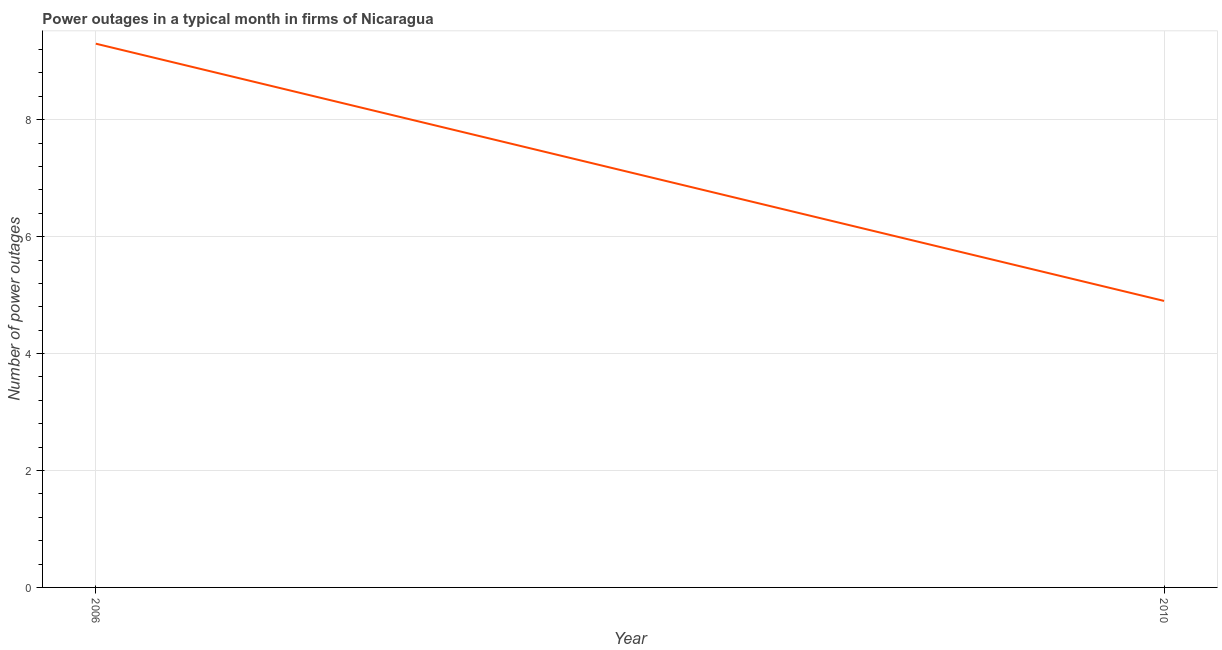What is the number of power outages in 2006?
Your answer should be very brief. 9.3. What is the sum of the number of power outages?
Provide a short and direct response. 14.2. What is the difference between the number of power outages in 2006 and 2010?
Your answer should be very brief. 4.4. What is the average number of power outages per year?
Provide a succinct answer. 7.1. What is the median number of power outages?
Provide a succinct answer. 7.1. Do a majority of the years between 2010 and 2006 (inclusive) have number of power outages greater than 8.8 ?
Provide a short and direct response. No. What is the ratio of the number of power outages in 2006 to that in 2010?
Your answer should be very brief. 1.9. In how many years, is the number of power outages greater than the average number of power outages taken over all years?
Give a very brief answer. 1. Does the number of power outages monotonically increase over the years?
Provide a short and direct response. No. How many lines are there?
Your response must be concise. 1. How many years are there in the graph?
Your response must be concise. 2. What is the difference between two consecutive major ticks on the Y-axis?
Make the answer very short. 2. Are the values on the major ticks of Y-axis written in scientific E-notation?
Provide a succinct answer. No. What is the title of the graph?
Keep it short and to the point. Power outages in a typical month in firms of Nicaragua. What is the label or title of the Y-axis?
Make the answer very short. Number of power outages. What is the Number of power outages in 2010?
Your answer should be very brief. 4.9. What is the ratio of the Number of power outages in 2006 to that in 2010?
Provide a succinct answer. 1.9. 